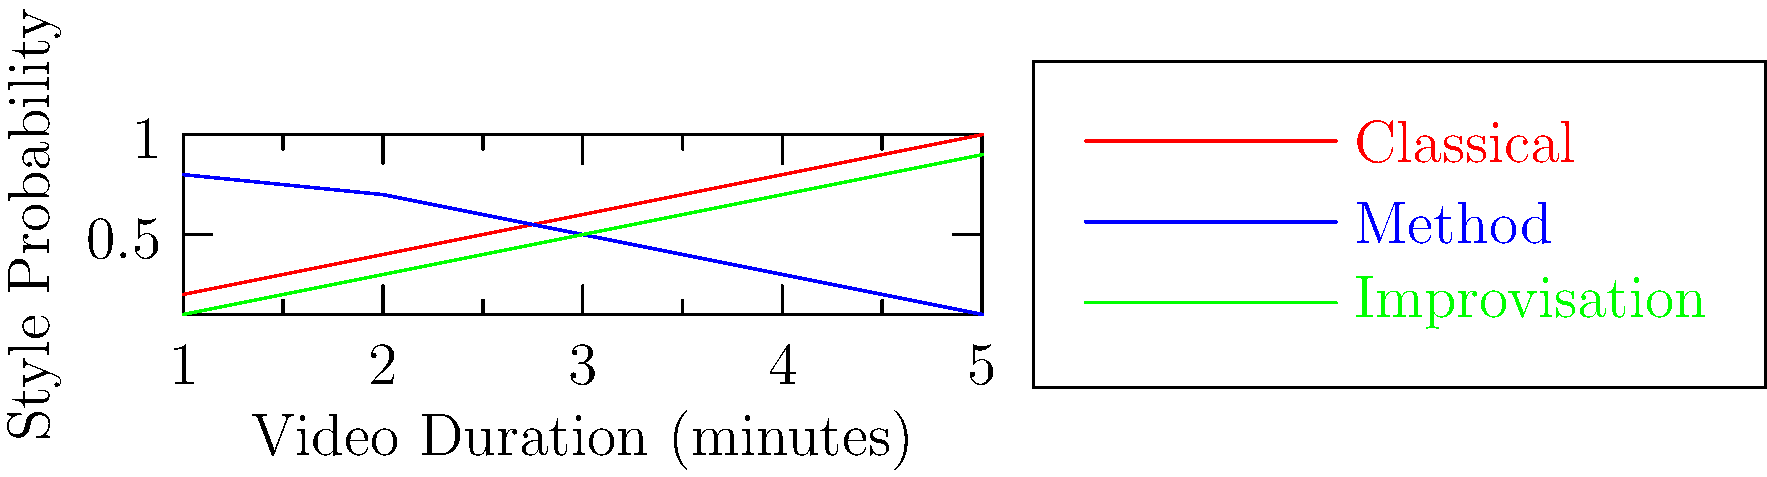In a machine learning model for classifying acting styles, you're analyzing the probability of different styles over the duration of a performance. Based on the graph, which acting style shows a consistently increasing probability as the video duration increases? To answer this question, we need to analyze the trends of each acting style represented in the graph:

1. Classical (red line):
   - Starts at a low probability and consistently increases throughout the video duration.
   - The line moves from approximately 0.2 to 1.0 probability.

2. Method (blue line):
   - Starts at a high probability and consistently decreases throughout the video duration.
   - The line moves from approximately 0.8 to 0.1 probability.

3. Improvisation (green line):
   - Starts at a low probability and consistently increases throughout the video duration.
   - The line moves from approximately 0.1 to 0.9 probability.

Among these three styles, only Classical and Improvisation show an increasing trend. However, the question asks for the style that shows a "consistently increasing probability," which is more accurately represented by the Classical style (red line). The Improvisation style also increases but starts lower and doesn't reach as high a probability by the end of the duration.

Therefore, the acting style that shows a consistently increasing probability as the video duration increases is the Classical style.
Answer: Classical 